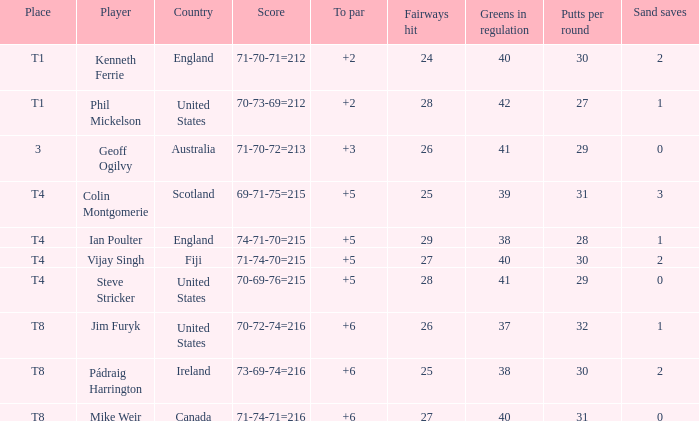What player was place of t1 in To Par and had a score of 70-73-69=212? 2.0. 